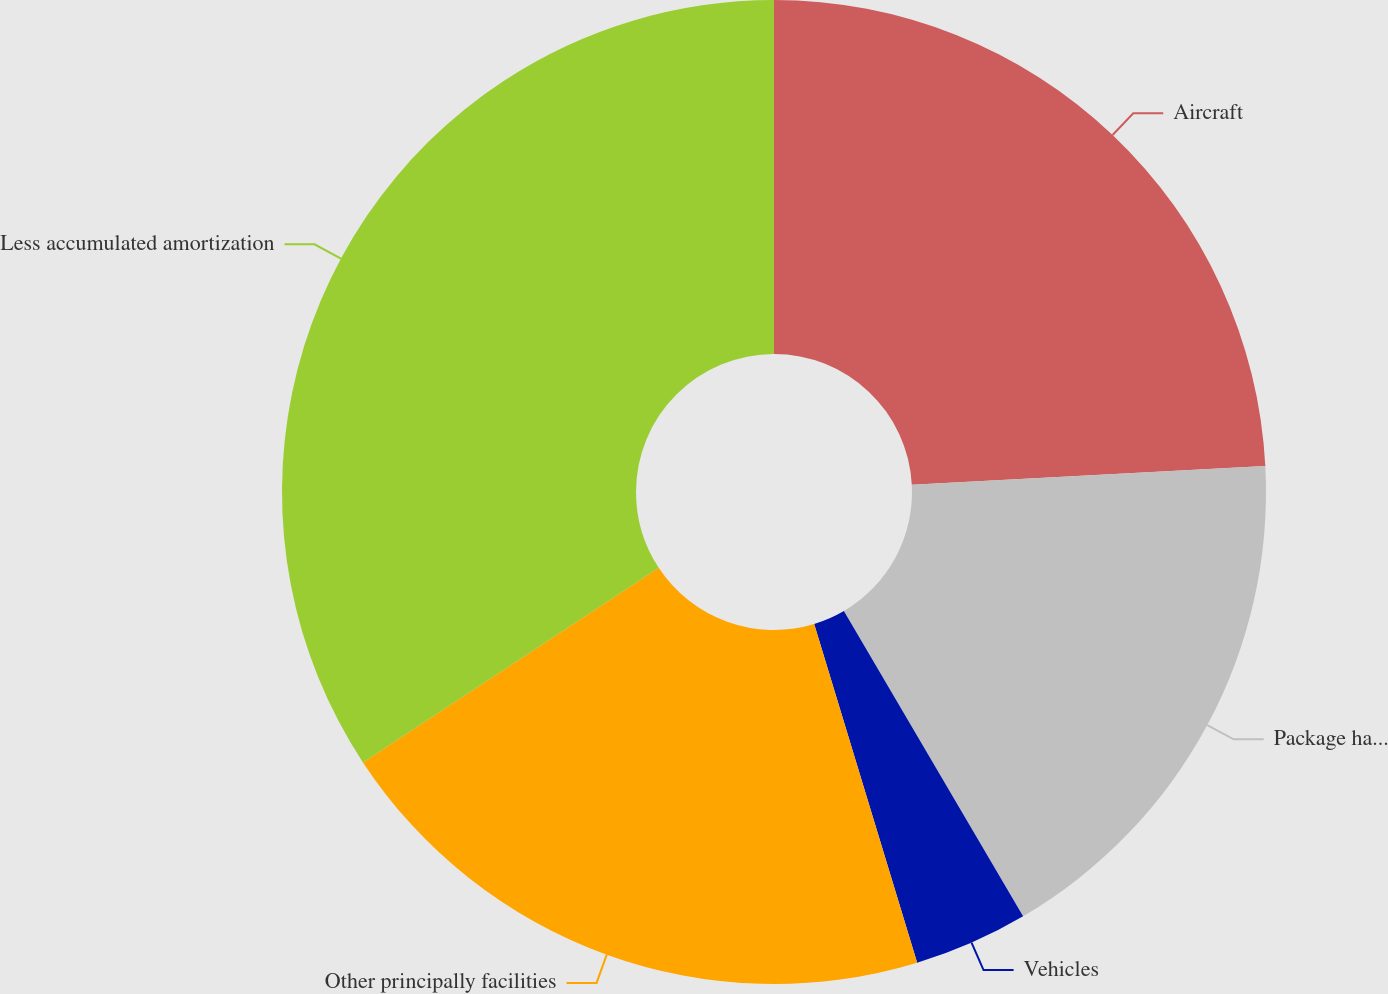Convert chart to OTSL. <chart><loc_0><loc_0><loc_500><loc_500><pie_chart><fcel>Aircraft<fcel>Package handling and ground<fcel>Vehicles<fcel>Other principally facilities<fcel>Less accumulated amortization<nl><fcel>24.16%<fcel>17.39%<fcel>3.75%<fcel>20.44%<fcel>34.26%<nl></chart> 